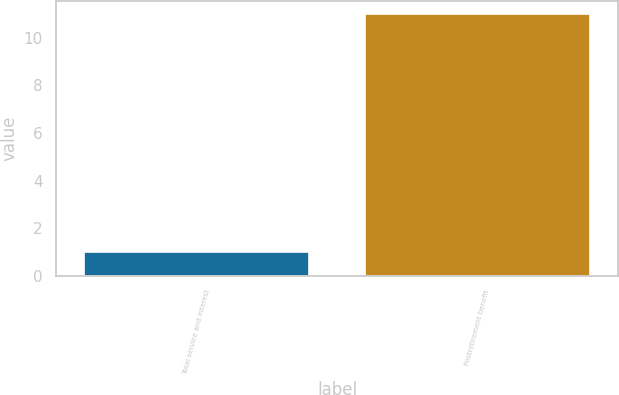Convert chart to OTSL. <chart><loc_0><loc_0><loc_500><loc_500><bar_chart><fcel>Total service and interest<fcel>Postretirement benefit<nl><fcel>1<fcel>11<nl></chart> 